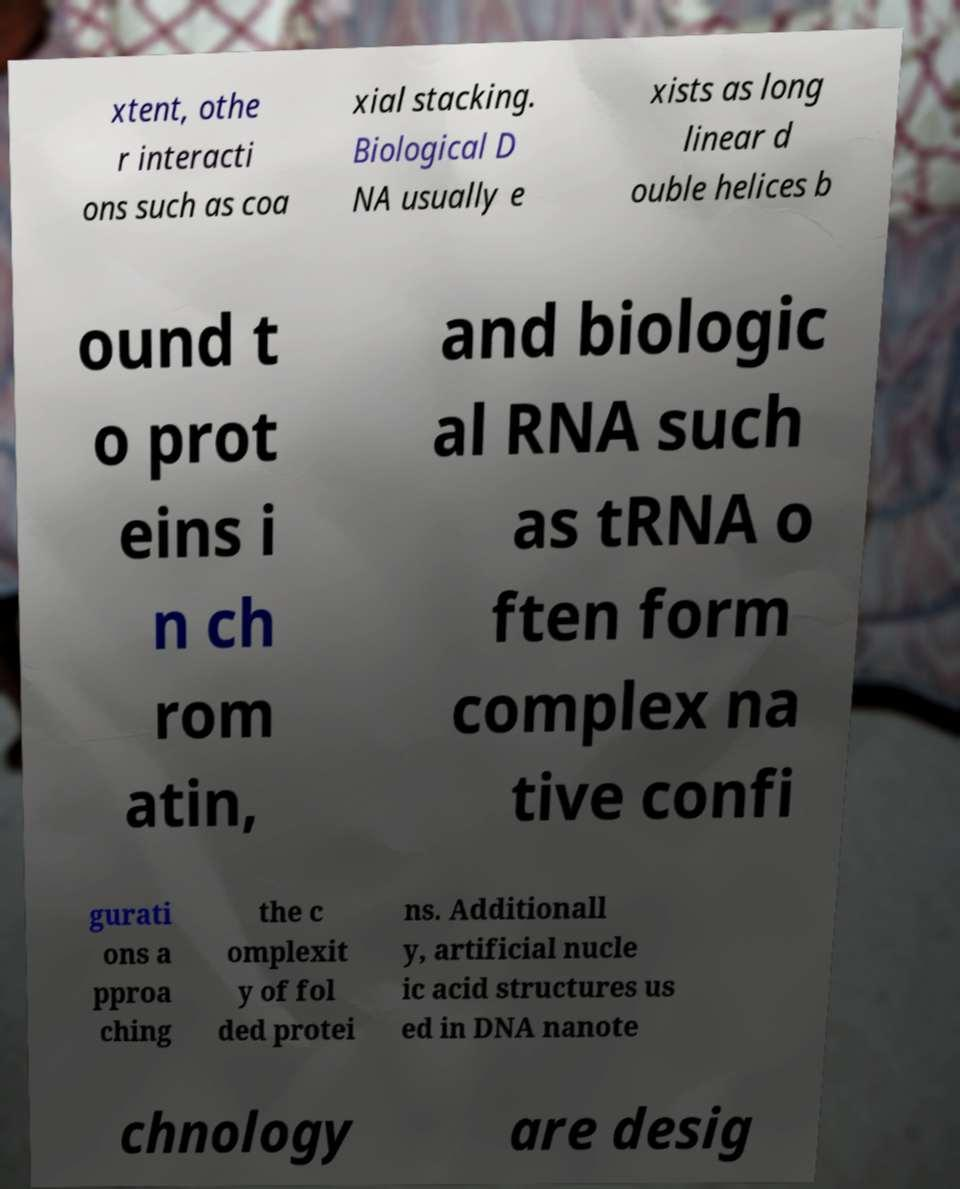I need the written content from this picture converted into text. Can you do that? xtent, othe r interacti ons such as coa xial stacking. Biological D NA usually e xists as long linear d ouble helices b ound t o prot eins i n ch rom atin, and biologic al RNA such as tRNA o ften form complex na tive confi gurati ons a pproa ching the c omplexit y of fol ded protei ns. Additionall y, artificial nucle ic acid structures us ed in DNA nanote chnology are desig 